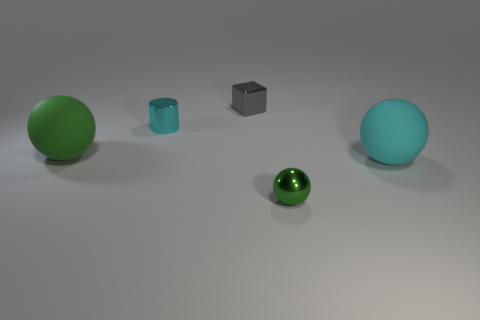Subtract all gray blocks. How many green balls are left? 2 Add 4 large yellow shiny cubes. How many objects exist? 9 Subtract all cylinders. How many objects are left? 4 Subtract 0 gray cylinders. How many objects are left? 5 Subtract all cyan rubber balls. Subtract all large green things. How many objects are left? 3 Add 1 cylinders. How many cylinders are left? 2 Add 5 small blue rubber cubes. How many small blue rubber cubes exist? 5 